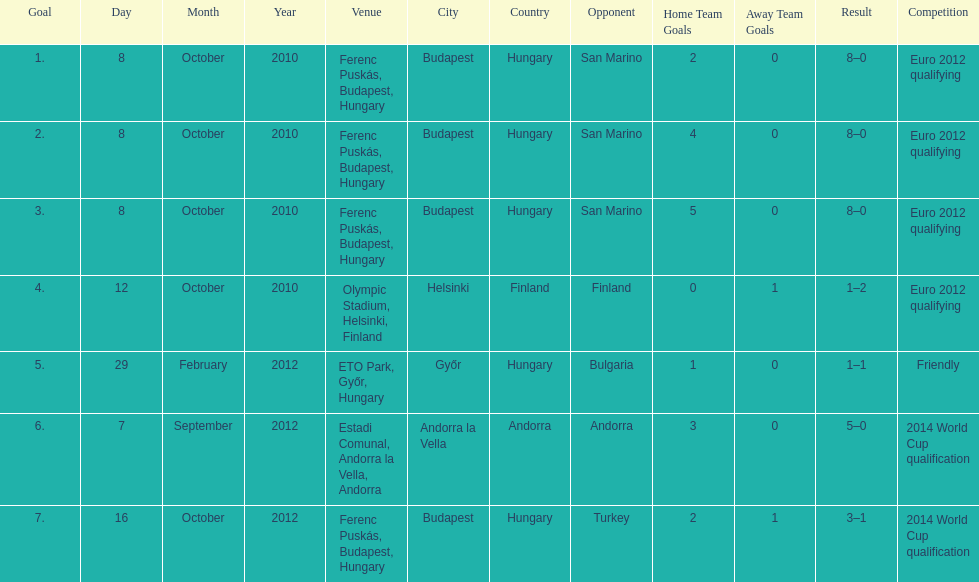In what year did ádám szalai make his next international goal after 2010? 2012. 